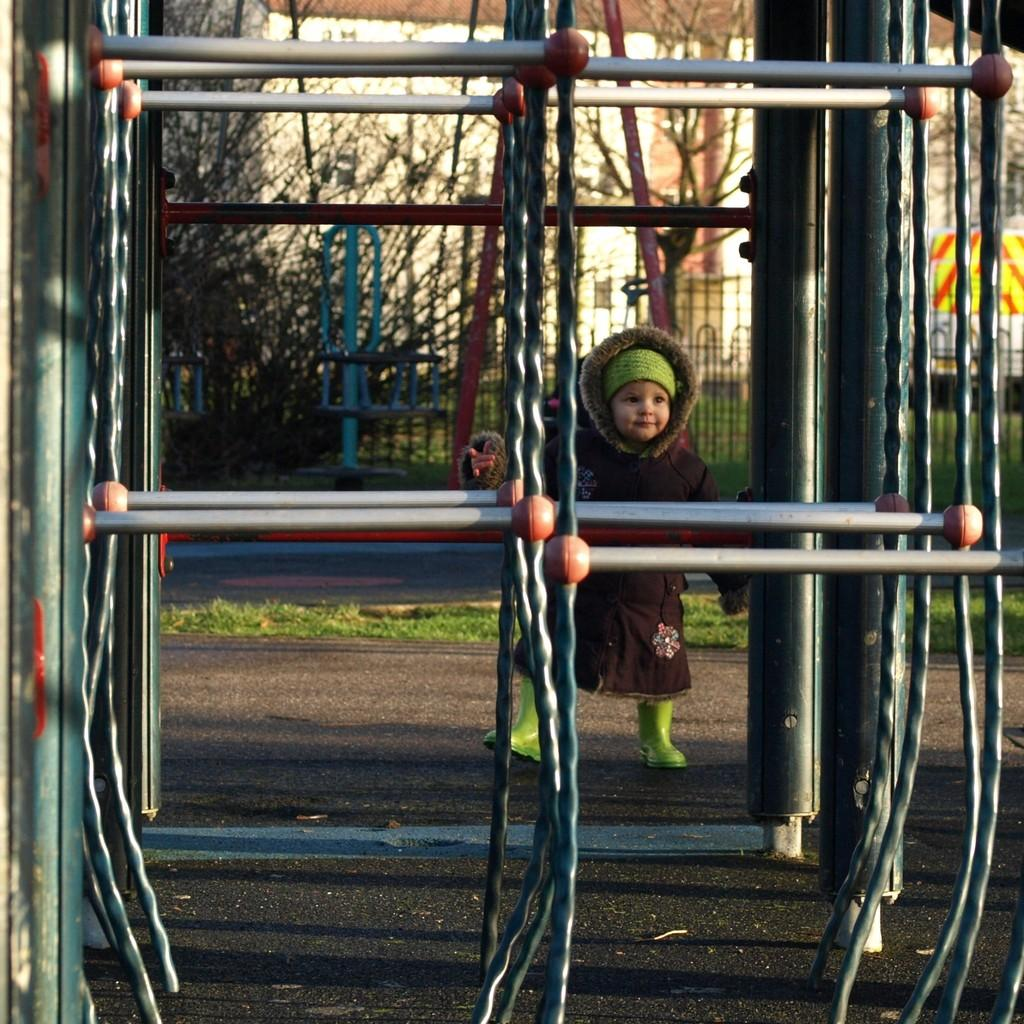What is the main subject of the image? There is a kid in the image. What objects can be seen in the image besides the kid? There are rods, grass, a road, a fence, trees, and a building in the background of the image. What type of terrain is visible in the image? The image shows grass and trees, which suggests a natural setting. What type of structure is visible in the background? There is a building in the background of the image. What type of meeting is taking place in the image? There is no meeting present in the image; it features a kid and various objects and structures. How does the fence support the trees in the image? The image does not show the fence supporting the trees; it is a separate object in the image. 